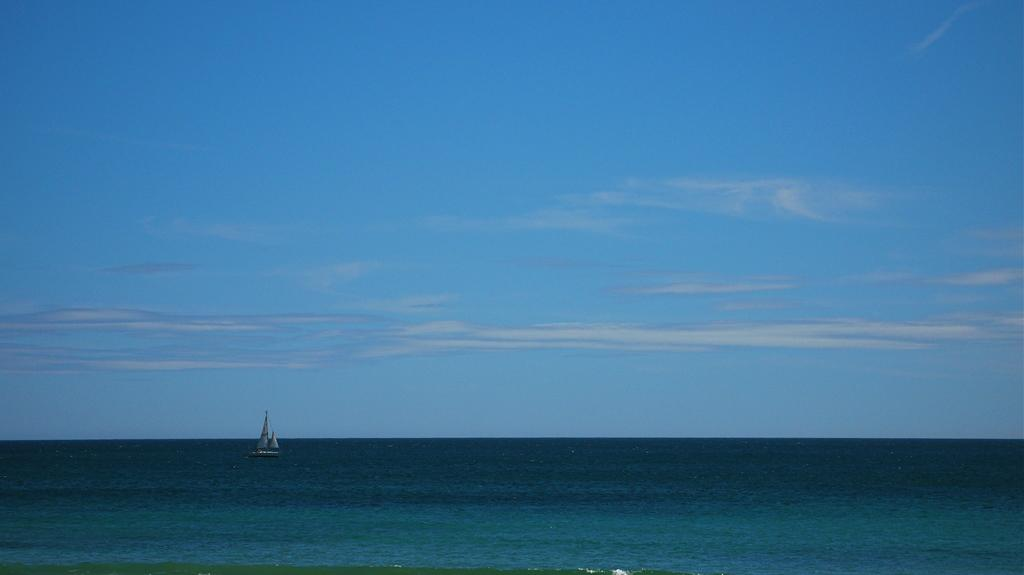What is the main subject of the image? The main subject of the image is a boat. What is the boat doing in the image? The boat is sailing on water in the image. What can be seen above the boat in the image? The sky is visible at the top of the image. Where is the drain located in the image? There is no drain present in the image. What type of picture is hanging on the wall in the image? There is no wall or picture present in the image; it features a boat sailing on water with the sky visible at the top. 